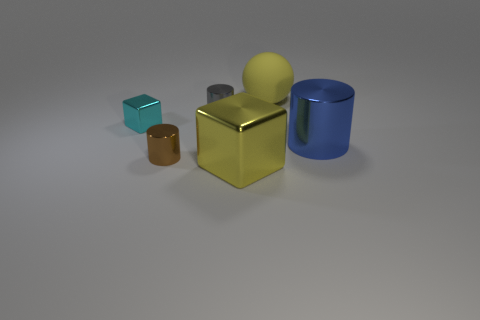Add 2 tiny cylinders. How many objects exist? 8 Subtract all spheres. How many objects are left? 5 Add 6 big objects. How many big objects exist? 9 Subtract 0 yellow cylinders. How many objects are left? 6 Subtract all large purple blocks. Subtract all cubes. How many objects are left? 4 Add 6 brown metallic cylinders. How many brown metallic cylinders are left? 7 